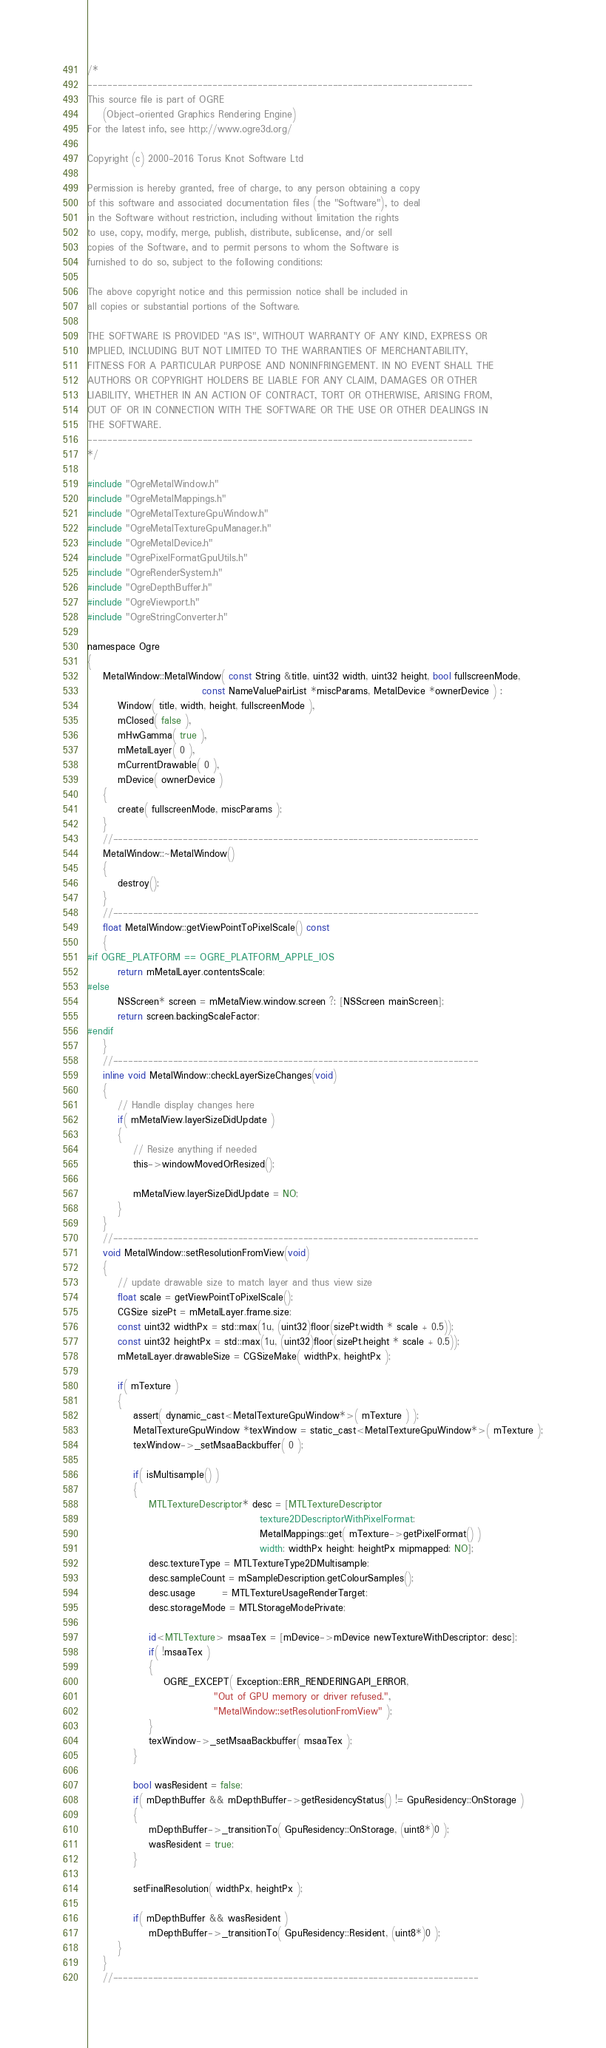<code> <loc_0><loc_0><loc_500><loc_500><_ObjectiveC_>/*
-----------------------------------------------------------------------------
This source file is part of OGRE
    (Object-oriented Graphics Rendering Engine)
For the latest info, see http://www.ogre3d.org/

Copyright (c) 2000-2016 Torus Knot Software Ltd

Permission is hereby granted, free of charge, to any person obtaining a copy
of this software and associated documentation files (the "Software"), to deal
in the Software without restriction, including without limitation the rights
to use, copy, modify, merge, publish, distribute, sublicense, and/or sell
copies of the Software, and to permit persons to whom the Software is
furnished to do so, subject to the following conditions:

The above copyright notice and this permission notice shall be included in
all copies or substantial portions of the Software.

THE SOFTWARE IS PROVIDED "AS IS", WITHOUT WARRANTY OF ANY KIND, EXPRESS OR
IMPLIED, INCLUDING BUT NOT LIMITED TO THE WARRANTIES OF MERCHANTABILITY,
FITNESS FOR A PARTICULAR PURPOSE AND NONINFRINGEMENT. IN NO EVENT SHALL THE
AUTHORS OR COPYRIGHT HOLDERS BE LIABLE FOR ANY CLAIM, DAMAGES OR OTHER
LIABILITY, WHETHER IN AN ACTION OF CONTRACT, TORT OR OTHERWISE, ARISING FROM,
OUT OF OR IN CONNECTION WITH THE SOFTWARE OR THE USE OR OTHER DEALINGS IN
THE SOFTWARE.
-----------------------------------------------------------------------------
*/

#include "OgreMetalWindow.h"
#include "OgreMetalMappings.h"
#include "OgreMetalTextureGpuWindow.h"
#include "OgreMetalTextureGpuManager.h"
#include "OgreMetalDevice.h"
#include "OgrePixelFormatGpuUtils.h"
#include "OgreRenderSystem.h"
#include "OgreDepthBuffer.h"
#include "OgreViewport.h"
#include "OgreStringConverter.h"

namespace Ogre
{
    MetalWindow::MetalWindow( const String &title, uint32 width, uint32 height, bool fullscreenMode,
                              const NameValuePairList *miscParams, MetalDevice *ownerDevice ) :
        Window( title, width, height, fullscreenMode ),
        mClosed( false ),
        mHwGamma( true ),
        mMetalLayer( 0 ),
        mCurrentDrawable( 0 ),
        mDevice( ownerDevice )
    {
        create( fullscreenMode, miscParams );
    }
    //-------------------------------------------------------------------------
    MetalWindow::~MetalWindow()
    {
        destroy();
    }
    //-------------------------------------------------------------------------
    float MetalWindow::getViewPointToPixelScale() const
    {
#if OGRE_PLATFORM == OGRE_PLATFORM_APPLE_IOS
        return mMetalLayer.contentsScale;
#else
        NSScreen* screen = mMetalView.window.screen ?: [NSScreen mainScreen];
        return screen.backingScaleFactor;
#endif
    }
    //-------------------------------------------------------------------------
    inline void MetalWindow::checkLayerSizeChanges(void)
    {
        // Handle display changes here
        if( mMetalView.layerSizeDidUpdate )
        {
            // Resize anything if needed
            this->windowMovedOrResized();

            mMetalView.layerSizeDidUpdate = NO;
        }
    }
    //-------------------------------------------------------------------------
    void MetalWindow::setResolutionFromView(void)
    {
        // update drawable size to match layer and thus view size
        float scale = getViewPointToPixelScale();
        CGSize sizePt = mMetalLayer.frame.size;
        const uint32 widthPx = std::max(1u, (uint32)floor(sizePt.width * scale + 0.5));
        const uint32 heightPx = std::max(1u, (uint32)floor(sizePt.height * scale + 0.5));
        mMetalLayer.drawableSize = CGSizeMake( widthPx, heightPx );

        if( mTexture )
        {
            assert( dynamic_cast<MetalTextureGpuWindow*>( mTexture ) );
            MetalTextureGpuWindow *texWindow = static_cast<MetalTextureGpuWindow*>( mTexture );
            texWindow->_setMsaaBackbuffer( 0 );

            if( isMultisample() )
            {
                MTLTextureDescriptor* desc = [MTLTextureDescriptor
                                             texture2DDescriptorWithPixelFormat:
                                             MetalMappings::get( mTexture->getPixelFormat() )
                                             width: widthPx height: heightPx mipmapped: NO];
                desc.textureType = MTLTextureType2DMultisample;
                desc.sampleCount = mSampleDescription.getColourSamples();
                desc.usage       = MTLTextureUsageRenderTarget;
                desc.storageMode = MTLStorageModePrivate;

                id<MTLTexture> msaaTex = [mDevice->mDevice newTextureWithDescriptor: desc];
                if( !msaaTex )
                {
                    OGRE_EXCEPT( Exception::ERR_RENDERINGAPI_ERROR,
                                 "Out of GPU memory or driver refused.",
                                 "MetalWindow::setResolutionFromView" );
                }
                texWindow->_setMsaaBackbuffer( msaaTex );
            }

            bool wasResident = false;
            if( mDepthBuffer && mDepthBuffer->getResidencyStatus() != GpuResidency::OnStorage )
            {
                mDepthBuffer->_transitionTo( GpuResidency::OnStorage, (uint8*)0 );
                wasResident = true;
            }

            setFinalResolution( widthPx, heightPx );

            if( mDepthBuffer && wasResident )
                mDepthBuffer->_transitionTo( GpuResidency::Resident, (uint8*)0 );
        }
    }
    //-------------------------------------------------------------------------</code> 